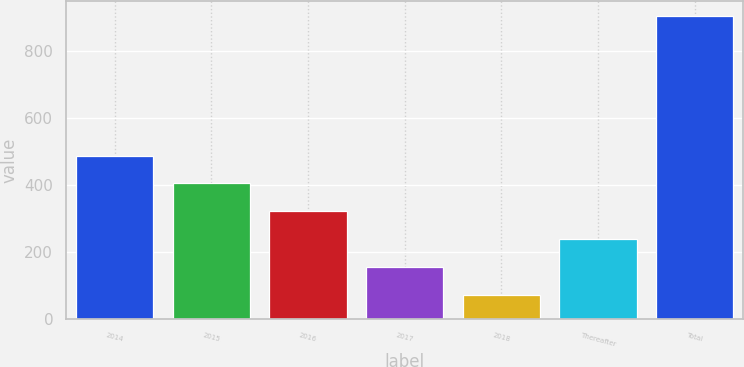<chart> <loc_0><loc_0><loc_500><loc_500><bar_chart><fcel>2014<fcel>2015<fcel>2016<fcel>2017<fcel>2018<fcel>Thereafter<fcel>Total<nl><fcel>488<fcel>404.8<fcel>321.6<fcel>155.2<fcel>72<fcel>238.4<fcel>904<nl></chart> 